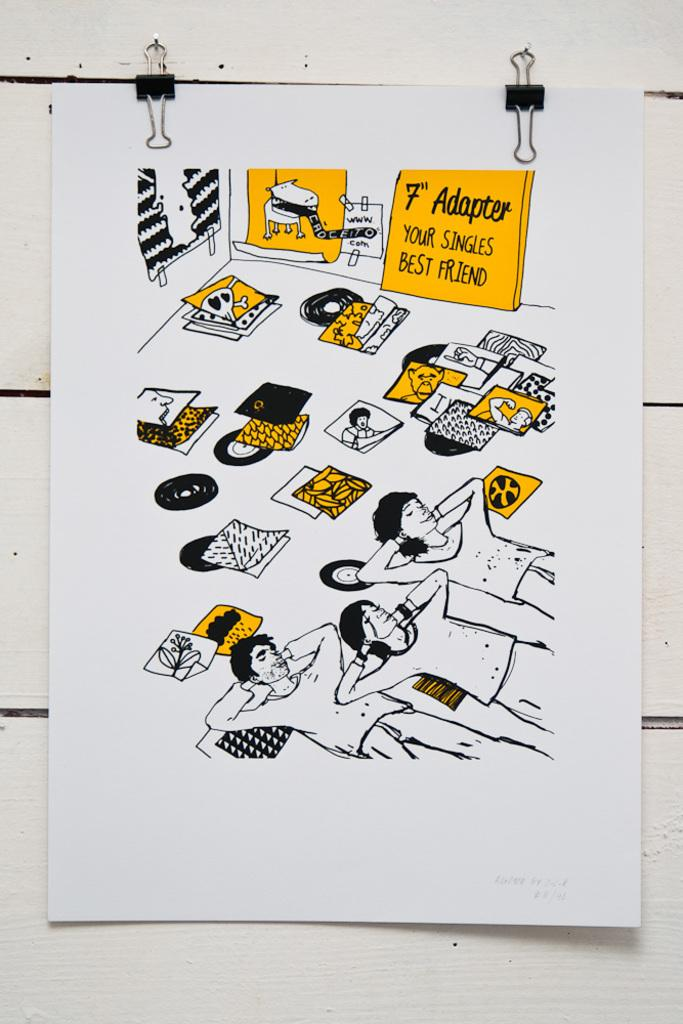<image>
Write a terse but informative summary of the picture. A bunch of vinyl records on the floor with a sign that says "7" Adapter" on it. 